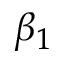Convert formula to latex. <formula><loc_0><loc_0><loc_500><loc_500>\beta _ { 1 }</formula> 